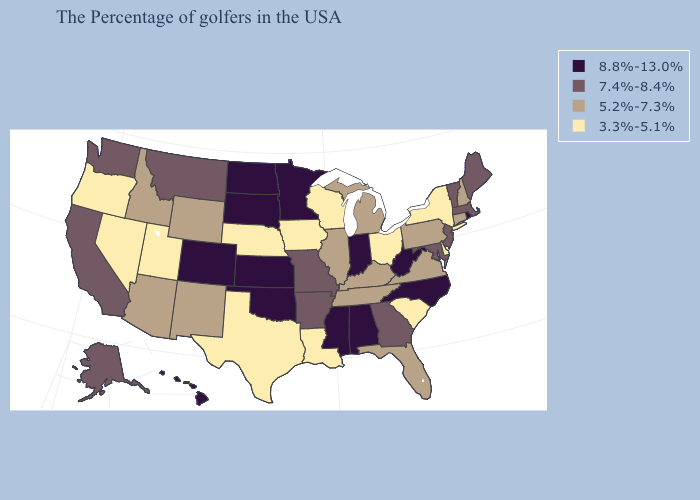What is the highest value in states that border Alabama?
Answer briefly. 8.8%-13.0%. Among the states that border North Dakota , which have the lowest value?
Keep it brief. Montana. Name the states that have a value in the range 3.3%-5.1%?
Answer briefly. New York, Delaware, South Carolina, Ohio, Wisconsin, Louisiana, Iowa, Nebraska, Texas, Utah, Nevada, Oregon. Among the states that border California , does Oregon have the highest value?
Give a very brief answer. No. Name the states that have a value in the range 5.2%-7.3%?
Short answer required. New Hampshire, Connecticut, Pennsylvania, Virginia, Florida, Michigan, Kentucky, Tennessee, Illinois, Wyoming, New Mexico, Arizona, Idaho. What is the value of Florida?
Short answer required. 5.2%-7.3%. What is the lowest value in the USA?
Concise answer only. 3.3%-5.1%. Which states have the highest value in the USA?
Keep it brief. Rhode Island, North Carolina, West Virginia, Indiana, Alabama, Mississippi, Minnesota, Kansas, Oklahoma, South Dakota, North Dakota, Colorado, Hawaii. What is the value of Iowa?
Keep it brief. 3.3%-5.1%. Does Maryland have the highest value in the USA?
Keep it brief. No. Which states hav the highest value in the West?
Answer briefly. Colorado, Hawaii. Does Minnesota have a higher value than Colorado?
Write a very short answer. No. What is the value of Nevada?
Answer briefly. 3.3%-5.1%. Does Delaware have the lowest value in the USA?
Be succinct. Yes. Does Oklahoma have the highest value in the USA?
Give a very brief answer. Yes. 